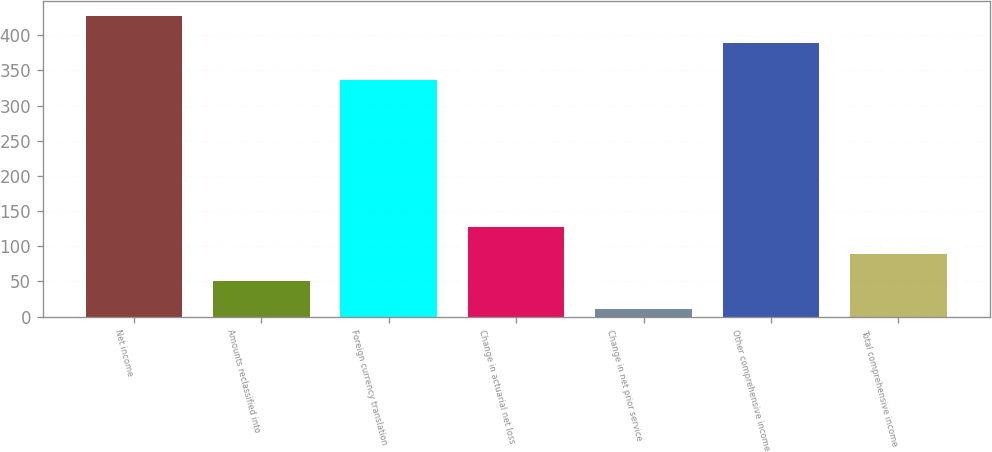Convert chart to OTSL. <chart><loc_0><loc_0><loc_500><loc_500><bar_chart><fcel>Net income<fcel>Amounts reclassified into<fcel>Foreign currency translation<fcel>Change in actuarial net loss<fcel>Change in net prior service<fcel>Other comprehensive income<fcel>Total comprehensive income<nl><fcel>428<fcel>50<fcel>336<fcel>128<fcel>11<fcel>389<fcel>89<nl></chart> 